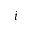Convert formula to latex. <formula><loc_0><loc_0><loc_500><loc_500>i</formula> 